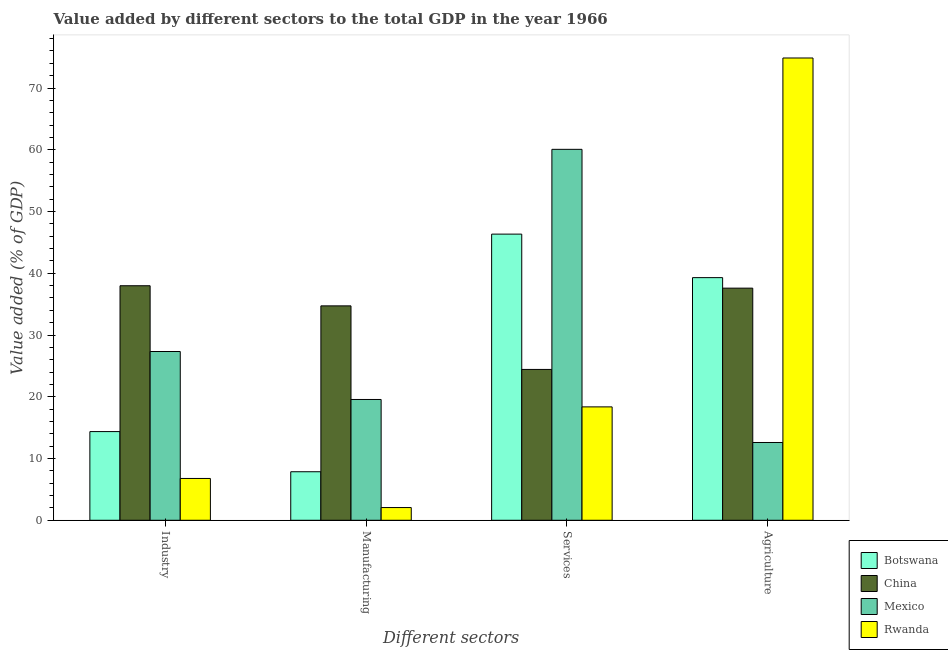How many different coloured bars are there?
Give a very brief answer. 4. How many groups of bars are there?
Give a very brief answer. 4. What is the label of the 4th group of bars from the left?
Your response must be concise. Agriculture. What is the value added by industrial sector in Botswana?
Provide a succinct answer. 14.36. Across all countries, what is the maximum value added by services sector?
Provide a short and direct response. 60.07. Across all countries, what is the minimum value added by services sector?
Provide a succinct answer. 18.36. What is the total value added by agricultural sector in the graph?
Provide a succinct answer. 164.35. What is the difference between the value added by manufacturing sector in China and that in Botswana?
Your answer should be compact. 26.86. What is the difference between the value added by services sector in China and the value added by agricultural sector in Botswana?
Keep it short and to the point. -14.87. What is the average value added by agricultural sector per country?
Ensure brevity in your answer.  41.09. What is the difference between the value added by industrial sector and value added by agricultural sector in China?
Your response must be concise. 0.39. What is the ratio of the value added by services sector in Botswana to that in Rwanda?
Ensure brevity in your answer.  2.52. What is the difference between the highest and the second highest value added by industrial sector?
Your answer should be compact. 10.65. What is the difference between the highest and the lowest value added by agricultural sector?
Make the answer very short. 62.27. Is it the case that in every country, the sum of the value added by manufacturing sector and value added by services sector is greater than the sum of value added by agricultural sector and value added by industrial sector?
Provide a succinct answer. No. Is it the case that in every country, the sum of the value added by industrial sector and value added by manufacturing sector is greater than the value added by services sector?
Your response must be concise. No. How many countries are there in the graph?
Offer a terse response. 4. Does the graph contain any zero values?
Offer a terse response. No. Does the graph contain grids?
Your response must be concise. No. How many legend labels are there?
Your answer should be very brief. 4. What is the title of the graph?
Provide a short and direct response. Value added by different sectors to the total GDP in the year 1966. What is the label or title of the X-axis?
Keep it short and to the point. Different sectors. What is the label or title of the Y-axis?
Your response must be concise. Value added (% of GDP). What is the Value added (% of GDP) in Botswana in Industry?
Make the answer very short. 14.36. What is the Value added (% of GDP) in China in Industry?
Your answer should be very brief. 37.98. What is the Value added (% of GDP) of Mexico in Industry?
Keep it short and to the point. 27.33. What is the Value added (% of GDP) in Rwanda in Industry?
Your answer should be very brief. 6.77. What is the Value added (% of GDP) in Botswana in Manufacturing?
Keep it short and to the point. 7.86. What is the Value added (% of GDP) of China in Manufacturing?
Keep it short and to the point. 34.72. What is the Value added (% of GDP) of Mexico in Manufacturing?
Keep it short and to the point. 19.56. What is the Value added (% of GDP) in Rwanda in Manufacturing?
Make the answer very short. 2.06. What is the Value added (% of GDP) of Botswana in Services?
Your answer should be very brief. 46.34. What is the Value added (% of GDP) of China in Services?
Your answer should be compact. 24.43. What is the Value added (% of GDP) of Mexico in Services?
Your answer should be very brief. 60.07. What is the Value added (% of GDP) of Rwanda in Services?
Ensure brevity in your answer.  18.36. What is the Value added (% of GDP) in Botswana in Agriculture?
Make the answer very short. 39.3. What is the Value added (% of GDP) of China in Agriculture?
Your response must be concise. 37.59. What is the Value added (% of GDP) in Mexico in Agriculture?
Ensure brevity in your answer.  12.6. What is the Value added (% of GDP) of Rwanda in Agriculture?
Ensure brevity in your answer.  74.87. Across all Different sectors, what is the maximum Value added (% of GDP) in Botswana?
Your answer should be very brief. 46.34. Across all Different sectors, what is the maximum Value added (% of GDP) of China?
Offer a very short reply. 37.98. Across all Different sectors, what is the maximum Value added (% of GDP) in Mexico?
Ensure brevity in your answer.  60.07. Across all Different sectors, what is the maximum Value added (% of GDP) in Rwanda?
Offer a terse response. 74.87. Across all Different sectors, what is the minimum Value added (% of GDP) of Botswana?
Make the answer very short. 7.86. Across all Different sectors, what is the minimum Value added (% of GDP) in China?
Provide a short and direct response. 24.43. Across all Different sectors, what is the minimum Value added (% of GDP) in Mexico?
Ensure brevity in your answer.  12.6. Across all Different sectors, what is the minimum Value added (% of GDP) of Rwanda?
Your response must be concise. 2.06. What is the total Value added (% of GDP) of Botswana in the graph?
Offer a terse response. 107.86. What is the total Value added (% of GDP) of China in the graph?
Provide a short and direct response. 134.72. What is the total Value added (% of GDP) in Mexico in the graph?
Give a very brief answer. 119.56. What is the total Value added (% of GDP) of Rwanda in the graph?
Make the answer very short. 102.06. What is the difference between the Value added (% of GDP) of Botswana in Industry and that in Manufacturing?
Ensure brevity in your answer.  6.5. What is the difference between the Value added (% of GDP) of China in Industry and that in Manufacturing?
Your answer should be very brief. 3.26. What is the difference between the Value added (% of GDP) in Mexico in Industry and that in Manufacturing?
Ensure brevity in your answer.  7.77. What is the difference between the Value added (% of GDP) in Rwanda in Industry and that in Manufacturing?
Your answer should be compact. 4.71. What is the difference between the Value added (% of GDP) of Botswana in Industry and that in Services?
Ensure brevity in your answer.  -31.98. What is the difference between the Value added (% of GDP) in China in Industry and that in Services?
Your response must be concise. 13.55. What is the difference between the Value added (% of GDP) of Mexico in Industry and that in Services?
Your answer should be very brief. -32.74. What is the difference between the Value added (% of GDP) of Rwanda in Industry and that in Services?
Give a very brief answer. -11.59. What is the difference between the Value added (% of GDP) of Botswana in Industry and that in Agriculture?
Provide a short and direct response. -24.93. What is the difference between the Value added (% of GDP) in China in Industry and that in Agriculture?
Keep it short and to the point. 0.39. What is the difference between the Value added (% of GDP) of Mexico in Industry and that in Agriculture?
Offer a very short reply. 14.73. What is the difference between the Value added (% of GDP) of Rwanda in Industry and that in Agriculture?
Give a very brief answer. -68.1. What is the difference between the Value added (% of GDP) in Botswana in Manufacturing and that in Services?
Keep it short and to the point. -38.48. What is the difference between the Value added (% of GDP) of China in Manufacturing and that in Services?
Your answer should be compact. 10.29. What is the difference between the Value added (% of GDP) of Mexico in Manufacturing and that in Services?
Your response must be concise. -40.51. What is the difference between the Value added (% of GDP) of Rwanda in Manufacturing and that in Services?
Provide a short and direct response. -16.31. What is the difference between the Value added (% of GDP) in Botswana in Manufacturing and that in Agriculture?
Make the answer very short. -31.44. What is the difference between the Value added (% of GDP) of China in Manufacturing and that in Agriculture?
Provide a succinct answer. -2.87. What is the difference between the Value added (% of GDP) of Mexico in Manufacturing and that in Agriculture?
Your answer should be very brief. 6.96. What is the difference between the Value added (% of GDP) of Rwanda in Manufacturing and that in Agriculture?
Your response must be concise. -72.81. What is the difference between the Value added (% of GDP) in Botswana in Services and that in Agriculture?
Offer a terse response. 7.05. What is the difference between the Value added (% of GDP) of China in Services and that in Agriculture?
Ensure brevity in your answer.  -13.16. What is the difference between the Value added (% of GDP) of Mexico in Services and that in Agriculture?
Give a very brief answer. 47.48. What is the difference between the Value added (% of GDP) in Rwanda in Services and that in Agriculture?
Offer a very short reply. -56.5. What is the difference between the Value added (% of GDP) of Botswana in Industry and the Value added (% of GDP) of China in Manufacturing?
Ensure brevity in your answer.  -20.36. What is the difference between the Value added (% of GDP) of Botswana in Industry and the Value added (% of GDP) of Mexico in Manufacturing?
Your response must be concise. -5.2. What is the difference between the Value added (% of GDP) in Botswana in Industry and the Value added (% of GDP) in Rwanda in Manufacturing?
Offer a very short reply. 12.31. What is the difference between the Value added (% of GDP) of China in Industry and the Value added (% of GDP) of Mexico in Manufacturing?
Your response must be concise. 18.42. What is the difference between the Value added (% of GDP) in China in Industry and the Value added (% of GDP) in Rwanda in Manufacturing?
Ensure brevity in your answer.  35.92. What is the difference between the Value added (% of GDP) of Mexico in Industry and the Value added (% of GDP) of Rwanda in Manufacturing?
Give a very brief answer. 25.27. What is the difference between the Value added (% of GDP) of Botswana in Industry and the Value added (% of GDP) of China in Services?
Offer a very short reply. -10.06. What is the difference between the Value added (% of GDP) in Botswana in Industry and the Value added (% of GDP) in Mexico in Services?
Give a very brief answer. -45.71. What is the difference between the Value added (% of GDP) of Botswana in Industry and the Value added (% of GDP) of Rwanda in Services?
Your response must be concise. -4. What is the difference between the Value added (% of GDP) of China in Industry and the Value added (% of GDP) of Mexico in Services?
Ensure brevity in your answer.  -22.09. What is the difference between the Value added (% of GDP) of China in Industry and the Value added (% of GDP) of Rwanda in Services?
Your response must be concise. 19.62. What is the difference between the Value added (% of GDP) in Mexico in Industry and the Value added (% of GDP) in Rwanda in Services?
Your response must be concise. 8.97. What is the difference between the Value added (% of GDP) of Botswana in Industry and the Value added (% of GDP) of China in Agriculture?
Your answer should be very brief. -23.23. What is the difference between the Value added (% of GDP) in Botswana in Industry and the Value added (% of GDP) in Mexico in Agriculture?
Your answer should be compact. 1.77. What is the difference between the Value added (% of GDP) of Botswana in Industry and the Value added (% of GDP) of Rwanda in Agriculture?
Provide a succinct answer. -60.5. What is the difference between the Value added (% of GDP) of China in Industry and the Value added (% of GDP) of Mexico in Agriculture?
Your answer should be compact. 25.39. What is the difference between the Value added (% of GDP) in China in Industry and the Value added (% of GDP) in Rwanda in Agriculture?
Offer a very short reply. -36.89. What is the difference between the Value added (% of GDP) of Mexico in Industry and the Value added (% of GDP) of Rwanda in Agriculture?
Your answer should be very brief. -47.54. What is the difference between the Value added (% of GDP) in Botswana in Manufacturing and the Value added (% of GDP) in China in Services?
Your response must be concise. -16.57. What is the difference between the Value added (% of GDP) of Botswana in Manufacturing and the Value added (% of GDP) of Mexico in Services?
Offer a very short reply. -52.21. What is the difference between the Value added (% of GDP) of Botswana in Manufacturing and the Value added (% of GDP) of Rwanda in Services?
Offer a very short reply. -10.5. What is the difference between the Value added (% of GDP) of China in Manufacturing and the Value added (% of GDP) of Mexico in Services?
Give a very brief answer. -25.35. What is the difference between the Value added (% of GDP) of China in Manufacturing and the Value added (% of GDP) of Rwanda in Services?
Keep it short and to the point. 16.36. What is the difference between the Value added (% of GDP) in Mexico in Manufacturing and the Value added (% of GDP) in Rwanda in Services?
Make the answer very short. 1.2. What is the difference between the Value added (% of GDP) of Botswana in Manufacturing and the Value added (% of GDP) of China in Agriculture?
Make the answer very short. -29.73. What is the difference between the Value added (% of GDP) in Botswana in Manufacturing and the Value added (% of GDP) in Mexico in Agriculture?
Your answer should be compact. -4.74. What is the difference between the Value added (% of GDP) of Botswana in Manufacturing and the Value added (% of GDP) of Rwanda in Agriculture?
Keep it short and to the point. -67.01. What is the difference between the Value added (% of GDP) in China in Manufacturing and the Value added (% of GDP) in Mexico in Agriculture?
Ensure brevity in your answer.  22.12. What is the difference between the Value added (% of GDP) of China in Manufacturing and the Value added (% of GDP) of Rwanda in Agriculture?
Keep it short and to the point. -40.15. What is the difference between the Value added (% of GDP) of Mexico in Manufacturing and the Value added (% of GDP) of Rwanda in Agriculture?
Your answer should be compact. -55.31. What is the difference between the Value added (% of GDP) in Botswana in Services and the Value added (% of GDP) in China in Agriculture?
Give a very brief answer. 8.75. What is the difference between the Value added (% of GDP) of Botswana in Services and the Value added (% of GDP) of Mexico in Agriculture?
Make the answer very short. 33.74. What is the difference between the Value added (% of GDP) of Botswana in Services and the Value added (% of GDP) of Rwanda in Agriculture?
Provide a short and direct response. -28.53. What is the difference between the Value added (% of GDP) of China in Services and the Value added (% of GDP) of Mexico in Agriculture?
Make the answer very short. 11.83. What is the difference between the Value added (% of GDP) of China in Services and the Value added (% of GDP) of Rwanda in Agriculture?
Your answer should be very brief. -50.44. What is the difference between the Value added (% of GDP) of Mexico in Services and the Value added (% of GDP) of Rwanda in Agriculture?
Your response must be concise. -14.79. What is the average Value added (% of GDP) of Botswana per Different sectors?
Keep it short and to the point. 26.96. What is the average Value added (% of GDP) in China per Different sectors?
Provide a succinct answer. 33.68. What is the average Value added (% of GDP) of Mexico per Different sectors?
Your answer should be compact. 29.89. What is the average Value added (% of GDP) in Rwanda per Different sectors?
Give a very brief answer. 25.51. What is the difference between the Value added (% of GDP) of Botswana and Value added (% of GDP) of China in Industry?
Make the answer very short. -23.62. What is the difference between the Value added (% of GDP) of Botswana and Value added (% of GDP) of Mexico in Industry?
Provide a succinct answer. -12.97. What is the difference between the Value added (% of GDP) of Botswana and Value added (% of GDP) of Rwanda in Industry?
Make the answer very short. 7.59. What is the difference between the Value added (% of GDP) of China and Value added (% of GDP) of Mexico in Industry?
Your answer should be very brief. 10.65. What is the difference between the Value added (% of GDP) in China and Value added (% of GDP) in Rwanda in Industry?
Offer a terse response. 31.21. What is the difference between the Value added (% of GDP) in Mexico and Value added (% of GDP) in Rwanda in Industry?
Offer a very short reply. 20.56. What is the difference between the Value added (% of GDP) of Botswana and Value added (% of GDP) of China in Manufacturing?
Your answer should be very brief. -26.86. What is the difference between the Value added (% of GDP) in Botswana and Value added (% of GDP) in Mexico in Manufacturing?
Make the answer very short. -11.7. What is the difference between the Value added (% of GDP) of Botswana and Value added (% of GDP) of Rwanda in Manufacturing?
Offer a terse response. 5.8. What is the difference between the Value added (% of GDP) in China and Value added (% of GDP) in Mexico in Manufacturing?
Give a very brief answer. 15.16. What is the difference between the Value added (% of GDP) of China and Value added (% of GDP) of Rwanda in Manufacturing?
Keep it short and to the point. 32.66. What is the difference between the Value added (% of GDP) of Mexico and Value added (% of GDP) of Rwanda in Manufacturing?
Ensure brevity in your answer.  17.5. What is the difference between the Value added (% of GDP) in Botswana and Value added (% of GDP) in China in Services?
Offer a terse response. 21.91. What is the difference between the Value added (% of GDP) in Botswana and Value added (% of GDP) in Mexico in Services?
Your answer should be very brief. -13.73. What is the difference between the Value added (% of GDP) of Botswana and Value added (% of GDP) of Rwanda in Services?
Offer a very short reply. 27.98. What is the difference between the Value added (% of GDP) in China and Value added (% of GDP) in Mexico in Services?
Offer a terse response. -35.65. What is the difference between the Value added (% of GDP) in China and Value added (% of GDP) in Rwanda in Services?
Your answer should be compact. 6.06. What is the difference between the Value added (% of GDP) in Mexico and Value added (% of GDP) in Rwanda in Services?
Your response must be concise. 41.71. What is the difference between the Value added (% of GDP) of Botswana and Value added (% of GDP) of China in Agriculture?
Provide a succinct answer. 1.7. What is the difference between the Value added (% of GDP) in Botswana and Value added (% of GDP) in Mexico in Agriculture?
Give a very brief answer. 26.7. What is the difference between the Value added (% of GDP) in Botswana and Value added (% of GDP) in Rwanda in Agriculture?
Offer a very short reply. -35.57. What is the difference between the Value added (% of GDP) of China and Value added (% of GDP) of Mexico in Agriculture?
Your answer should be very brief. 24.99. What is the difference between the Value added (% of GDP) in China and Value added (% of GDP) in Rwanda in Agriculture?
Provide a short and direct response. -37.28. What is the difference between the Value added (% of GDP) in Mexico and Value added (% of GDP) in Rwanda in Agriculture?
Provide a succinct answer. -62.27. What is the ratio of the Value added (% of GDP) of Botswana in Industry to that in Manufacturing?
Make the answer very short. 1.83. What is the ratio of the Value added (% of GDP) of China in Industry to that in Manufacturing?
Your answer should be very brief. 1.09. What is the ratio of the Value added (% of GDP) of Mexico in Industry to that in Manufacturing?
Your answer should be compact. 1.4. What is the ratio of the Value added (% of GDP) in Rwanda in Industry to that in Manufacturing?
Your answer should be very brief. 3.29. What is the ratio of the Value added (% of GDP) in Botswana in Industry to that in Services?
Offer a very short reply. 0.31. What is the ratio of the Value added (% of GDP) of China in Industry to that in Services?
Ensure brevity in your answer.  1.55. What is the ratio of the Value added (% of GDP) in Mexico in Industry to that in Services?
Offer a terse response. 0.46. What is the ratio of the Value added (% of GDP) of Rwanda in Industry to that in Services?
Keep it short and to the point. 0.37. What is the ratio of the Value added (% of GDP) in Botswana in Industry to that in Agriculture?
Provide a succinct answer. 0.37. What is the ratio of the Value added (% of GDP) of China in Industry to that in Agriculture?
Make the answer very short. 1.01. What is the ratio of the Value added (% of GDP) of Mexico in Industry to that in Agriculture?
Provide a short and direct response. 2.17. What is the ratio of the Value added (% of GDP) in Rwanda in Industry to that in Agriculture?
Provide a succinct answer. 0.09. What is the ratio of the Value added (% of GDP) of Botswana in Manufacturing to that in Services?
Give a very brief answer. 0.17. What is the ratio of the Value added (% of GDP) in China in Manufacturing to that in Services?
Your response must be concise. 1.42. What is the ratio of the Value added (% of GDP) of Mexico in Manufacturing to that in Services?
Offer a terse response. 0.33. What is the ratio of the Value added (% of GDP) in Rwanda in Manufacturing to that in Services?
Your answer should be compact. 0.11. What is the ratio of the Value added (% of GDP) in China in Manufacturing to that in Agriculture?
Your answer should be compact. 0.92. What is the ratio of the Value added (% of GDP) of Mexico in Manufacturing to that in Agriculture?
Give a very brief answer. 1.55. What is the ratio of the Value added (% of GDP) in Rwanda in Manufacturing to that in Agriculture?
Your response must be concise. 0.03. What is the ratio of the Value added (% of GDP) of Botswana in Services to that in Agriculture?
Provide a succinct answer. 1.18. What is the ratio of the Value added (% of GDP) in China in Services to that in Agriculture?
Ensure brevity in your answer.  0.65. What is the ratio of the Value added (% of GDP) in Mexico in Services to that in Agriculture?
Your response must be concise. 4.77. What is the ratio of the Value added (% of GDP) of Rwanda in Services to that in Agriculture?
Keep it short and to the point. 0.25. What is the difference between the highest and the second highest Value added (% of GDP) in Botswana?
Provide a succinct answer. 7.05. What is the difference between the highest and the second highest Value added (% of GDP) of China?
Offer a terse response. 0.39. What is the difference between the highest and the second highest Value added (% of GDP) in Mexico?
Give a very brief answer. 32.74. What is the difference between the highest and the second highest Value added (% of GDP) in Rwanda?
Offer a very short reply. 56.5. What is the difference between the highest and the lowest Value added (% of GDP) of Botswana?
Provide a short and direct response. 38.48. What is the difference between the highest and the lowest Value added (% of GDP) in China?
Keep it short and to the point. 13.55. What is the difference between the highest and the lowest Value added (% of GDP) of Mexico?
Make the answer very short. 47.48. What is the difference between the highest and the lowest Value added (% of GDP) in Rwanda?
Keep it short and to the point. 72.81. 